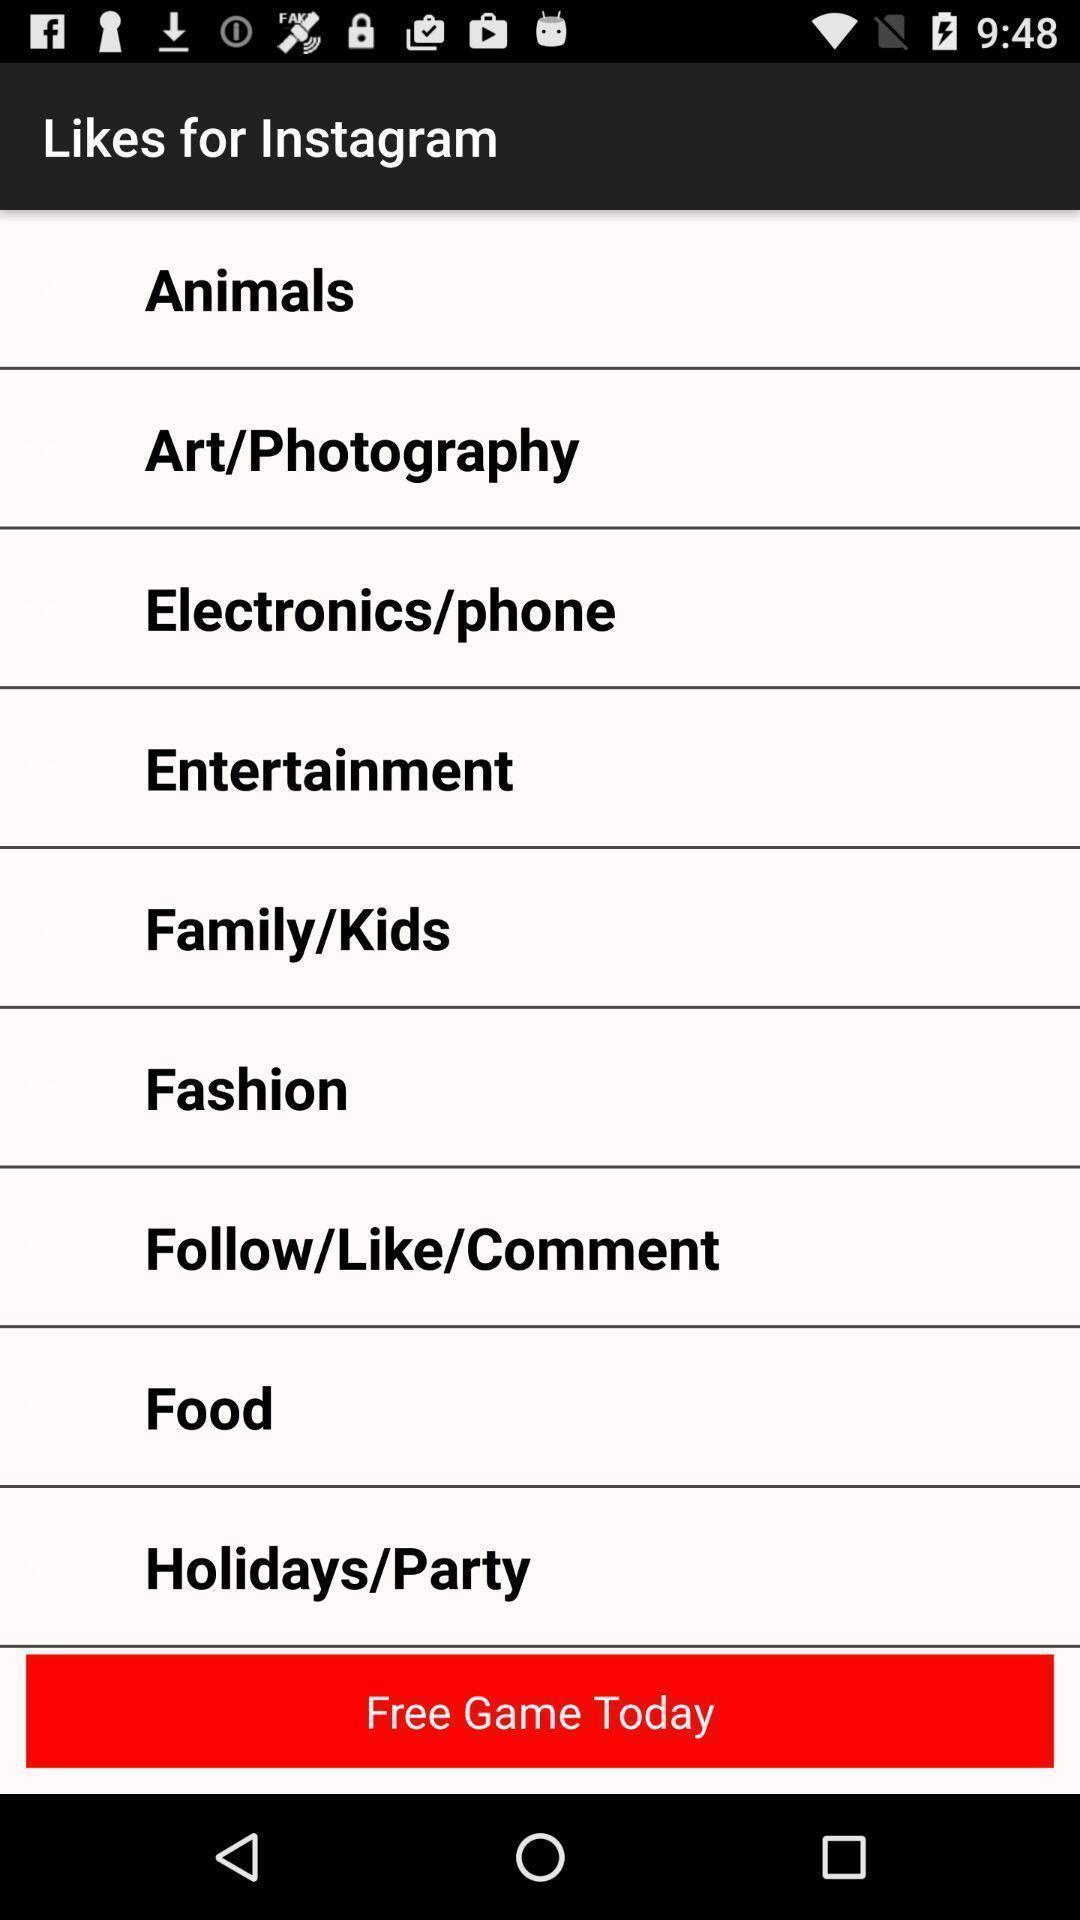Give me a summary of this screen capture. Screen shows multiple options in a social application. 